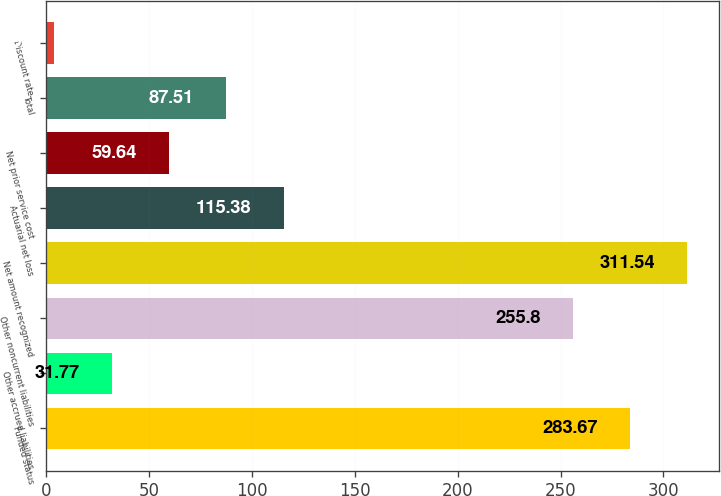Convert chart. <chart><loc_0><loc_0><loc_500><loc_500><bar_chart><fcel>Funded status<fcel>Other accrued liabilities<fcel>Other noncurrent liabilities<fcel>Net amount recognized<fcel>Actuarial net loss<fcel>Net prior service cost<fcel>Total<fcel>Discount rate<nl><fcel>283.67<fcel>31.77<fcel>255.8<fcel>311.54<fcel>115.38<fcel>59.64<fcel>87.51<fcel>3.9<nl></chart> 